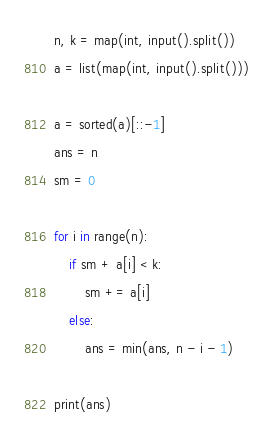<code> <loc_0><loc_0><loc_500><loc_500><_Python_>n, k = map(int, input().split())
a = list(map(int, input().split()))

a = sorted(a)[::-1]
ans = n
sm = 0

for i in range(n):
    if sm + a[i] < k:
        sm += a[i]
    else:
        ans = min(ans, n - i - 1)

print(ans)
</code> 